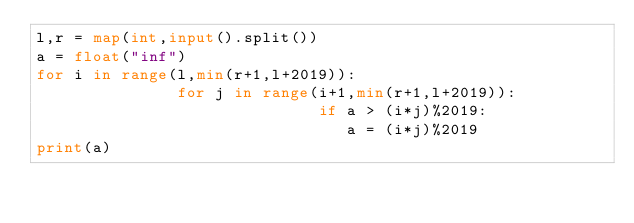<code> <loc_0><loc_0><loc_500><loc_500><_Python_>l,r = map(int,input().split())
a = float("inf")
for i in range(l,min(r+1,l+2019)):
               for j in range(i+1,min(r+1,l+2019)):
                              if a > (i*j)%2019:
                                 a = (i*j)%2019
print(a)</code> 